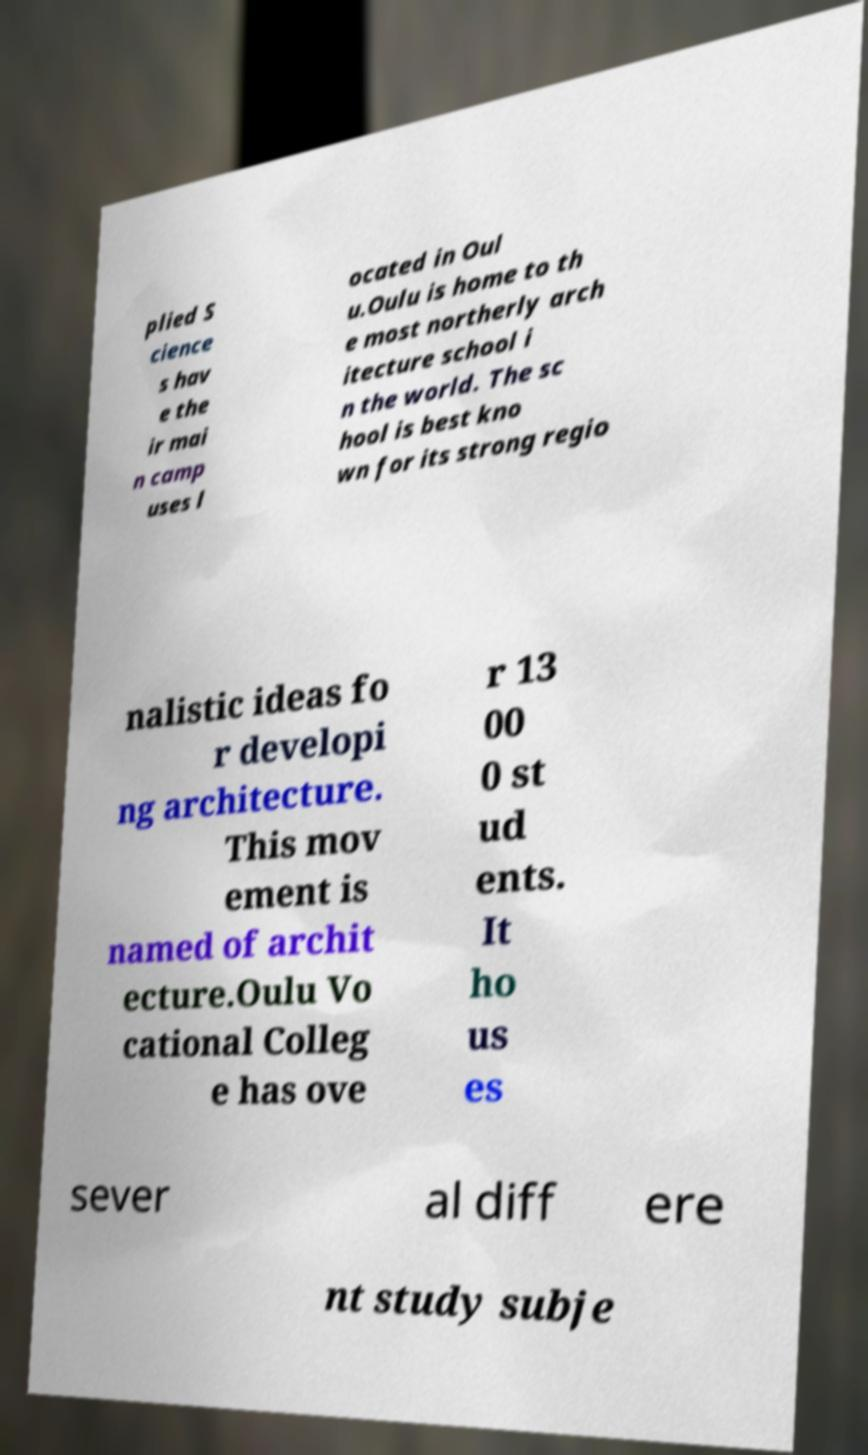What messages or text are displayed in this image? I need them in a readable, typed format. plied S cience s hav e the ir mai n camp uses l ocated in Oul u.Oulu is home to th e most northerly arch itecture school i n the world. The sc hool is best kno wn for its strong regio nalistic ideas fo r developi ng architecture. This mov ement is named of archit ecture.Oulu Vo cational Colleg e has ove r 13 00 0 st ud ents. It ho us es sever al diff ere nt study subje 